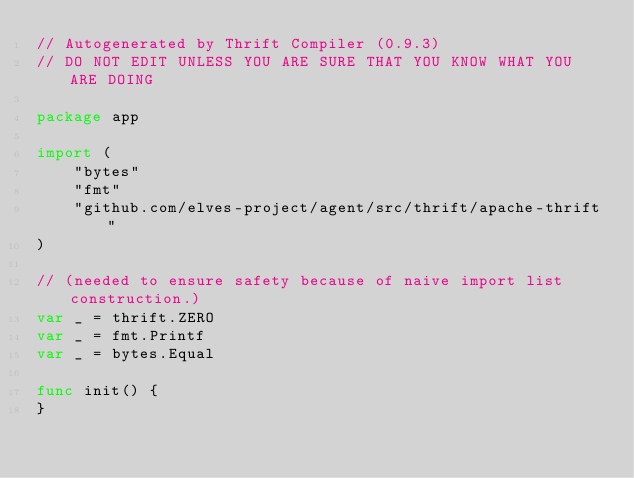Convert code to text. <code><loc_0><loc_0><loc_500><loc_500><_Go_>// Autogenerated by Thrift Compiler (0.9.3)
// DO NOT EDIT UNLESS YOU ARE SURE THAT YOU KNOW WHAT YOU ARE DOING

package app

import (
	"bytes"
	"fmt"
	"github.com/elves-project/agent/src/thrift/apache-thrift"
)

// (needed to ensure safety because of naive import list construction.)
var _ = thrift.ZERO
var _ = fmt.Printf
var _ = bytes.Equal

func init() {
}
</code> 